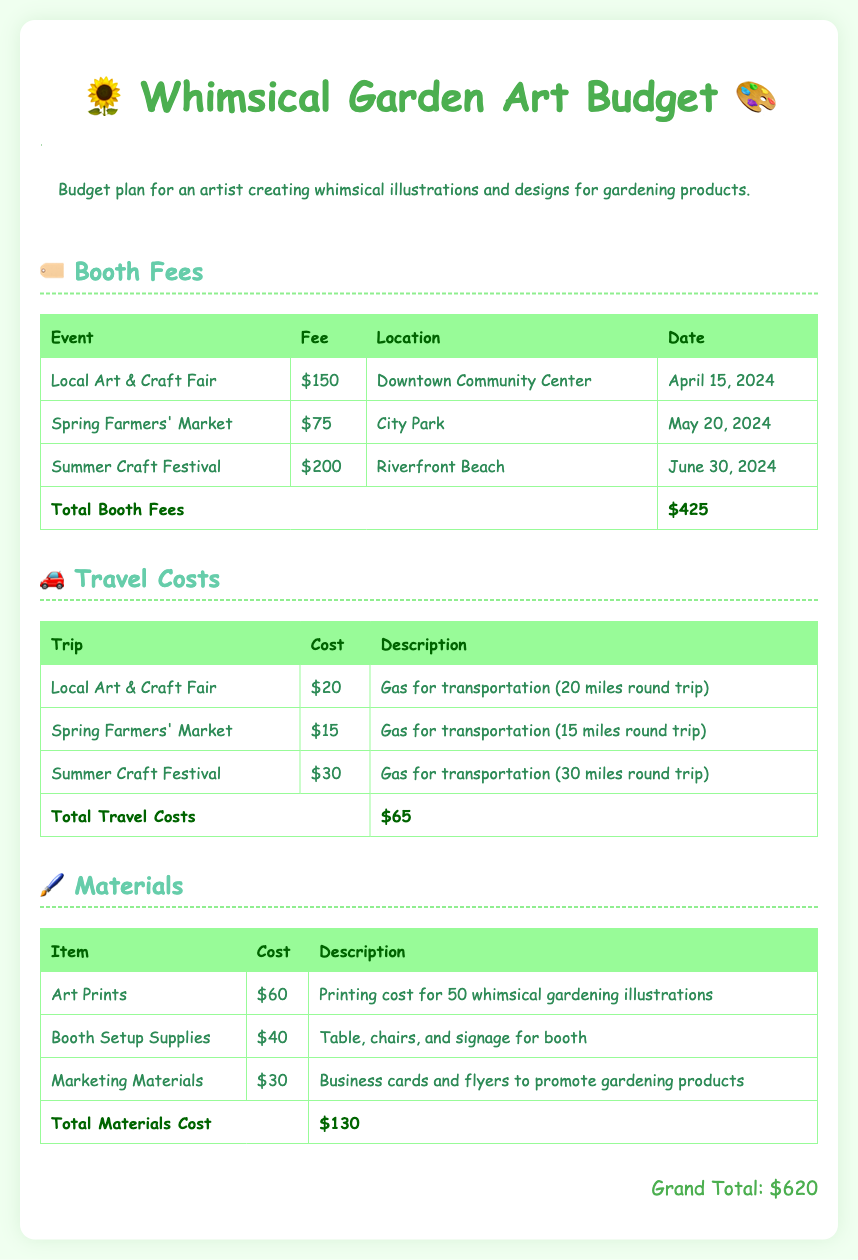What is the total booth fee for the Local Art & Craft Fair? The total booth fee for the Local Art & Craft Fair can be found in the booth fees section as $150.
Answer: $150 What is the cost of travel for the Summer Craft Festival? The cost for travel to the Summer Craft Festival is listed in the travel costs section as $30.
Answer: $30 How many art prints are being printed? The number of art prints being printed is mentioned in the materials section as 50.
Answer: 50 What location is the Spring Farmers' Market held at? The location for the Spring Farmers' Market is specified in the booth fees section as City Park.
Answer: City Park What is the total amount allocated for materials? The total amount for materials is found at the end of the materials section, which adds up to $130.
Answer: $130 Which event has the highest booth fee? By comparing the booth fees, the event with the highest fee is the Summer Craft Festival at $200.
Answer: Summer Craft Festival What is the grand total of the budget? The grand total is calculated by adding booth fees, travel costs, and materials costs, which totals to $620.
Answer: $620 What type of materials are included in the budget? In the materials section, items such as Art Prints, Booth Setup Supplies, and Marketing Materials are specified.
Answer: Art Prints What is the date of the Summer Craft Festival? The date of the Summer Craft Festival is given in the booth fees section as June 30, 2024.
Answer: June 30, 2024 